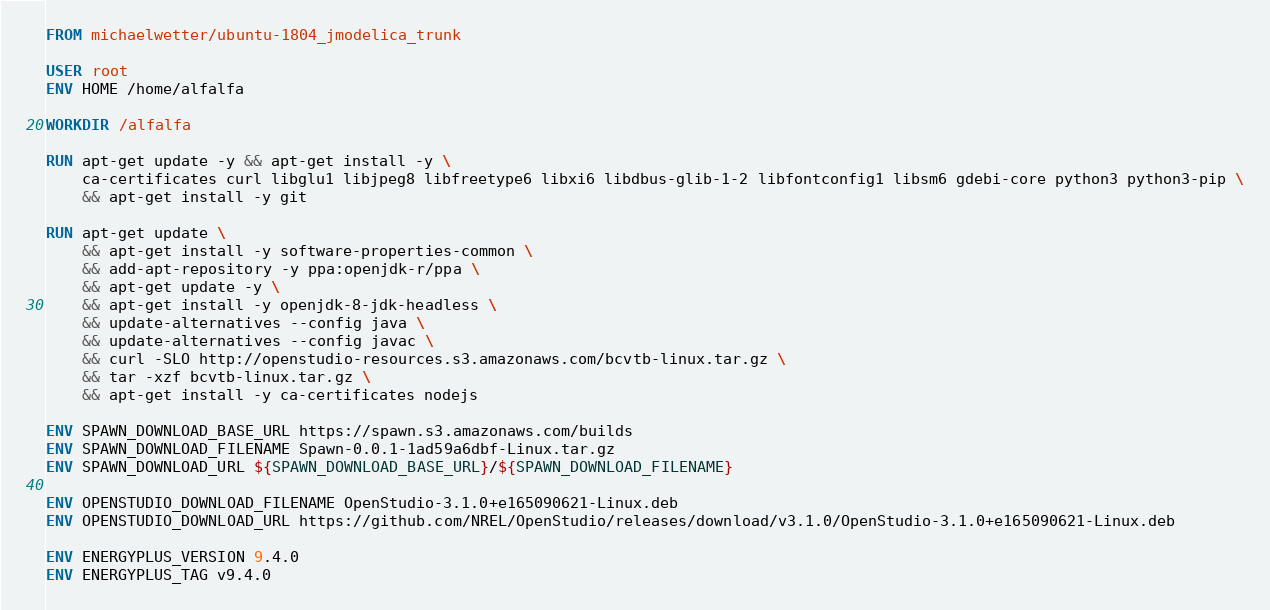<code> <loc_0><loc_0><loc_500><loc_500><_Dockerfile_>FROM michaelwetter/ubuntu-1804_jmodelica_trunk

USER root
ENV HOME /home/alfalfa

WORKDIR /alfalfa

RUN apt-get update -y && apt-get install -y \
    ca-certificates curl libglu1 libjpeg8 libfreetype6 libxi6 libdbus-glib-1-2 libfontconfig1 libsm6 gdebi-core python3 python3-pip \
    && apt-get install -y git

RUN apt-get update \
    && apt-get install -y software-properties-common \
    && add-apt-repository -y ppa:openjdk-r/ppa \
    && apt-get update -y \
    && apt-get install -y openjdk-8-jdk-headless \
    && update-alternatives --config java \
    && update-alternatives --config javac \
    && curl -SLO http://openstudio-resources.s3.amazonaws.com/bcvtb-linux.tar.gz \
    && tar -xzf bcvtb-linux.tar.gz \
    && apt-get install -y ca-certificates nodejs

ENV SPAWN_DOWNLOAD_BASE_URL https://spawn.s3.amazonaws.com/builds
ENV SPAWN_DOWNLOAD_FILENAME Spawn-0.0.1-1ad59a6dbf-Linux.tar.gz
ENV SPAWN_DOWNLOAD_URL ${SPAWN_DOWNLOAD_BASE_URL}/${SPAWN_DOWNLOAD_FILENAME}

ENV OPENSTUDIO_DOWNLOAD_FILENAME OpenStudio-3.1.0+e165090621-Linux.deb
ENV OPENSTUDIO_DOWNLOAD_URL https://github.com/NREL/OpenStudio/releases/download/v3.1.0/OpenStudio-3.1.0+e165090621-Linux.deb

ENV ENERGYPLUS_VERSION 9.4.0
ENV ENERGYPLUS_TAG v9.4.0</code> 